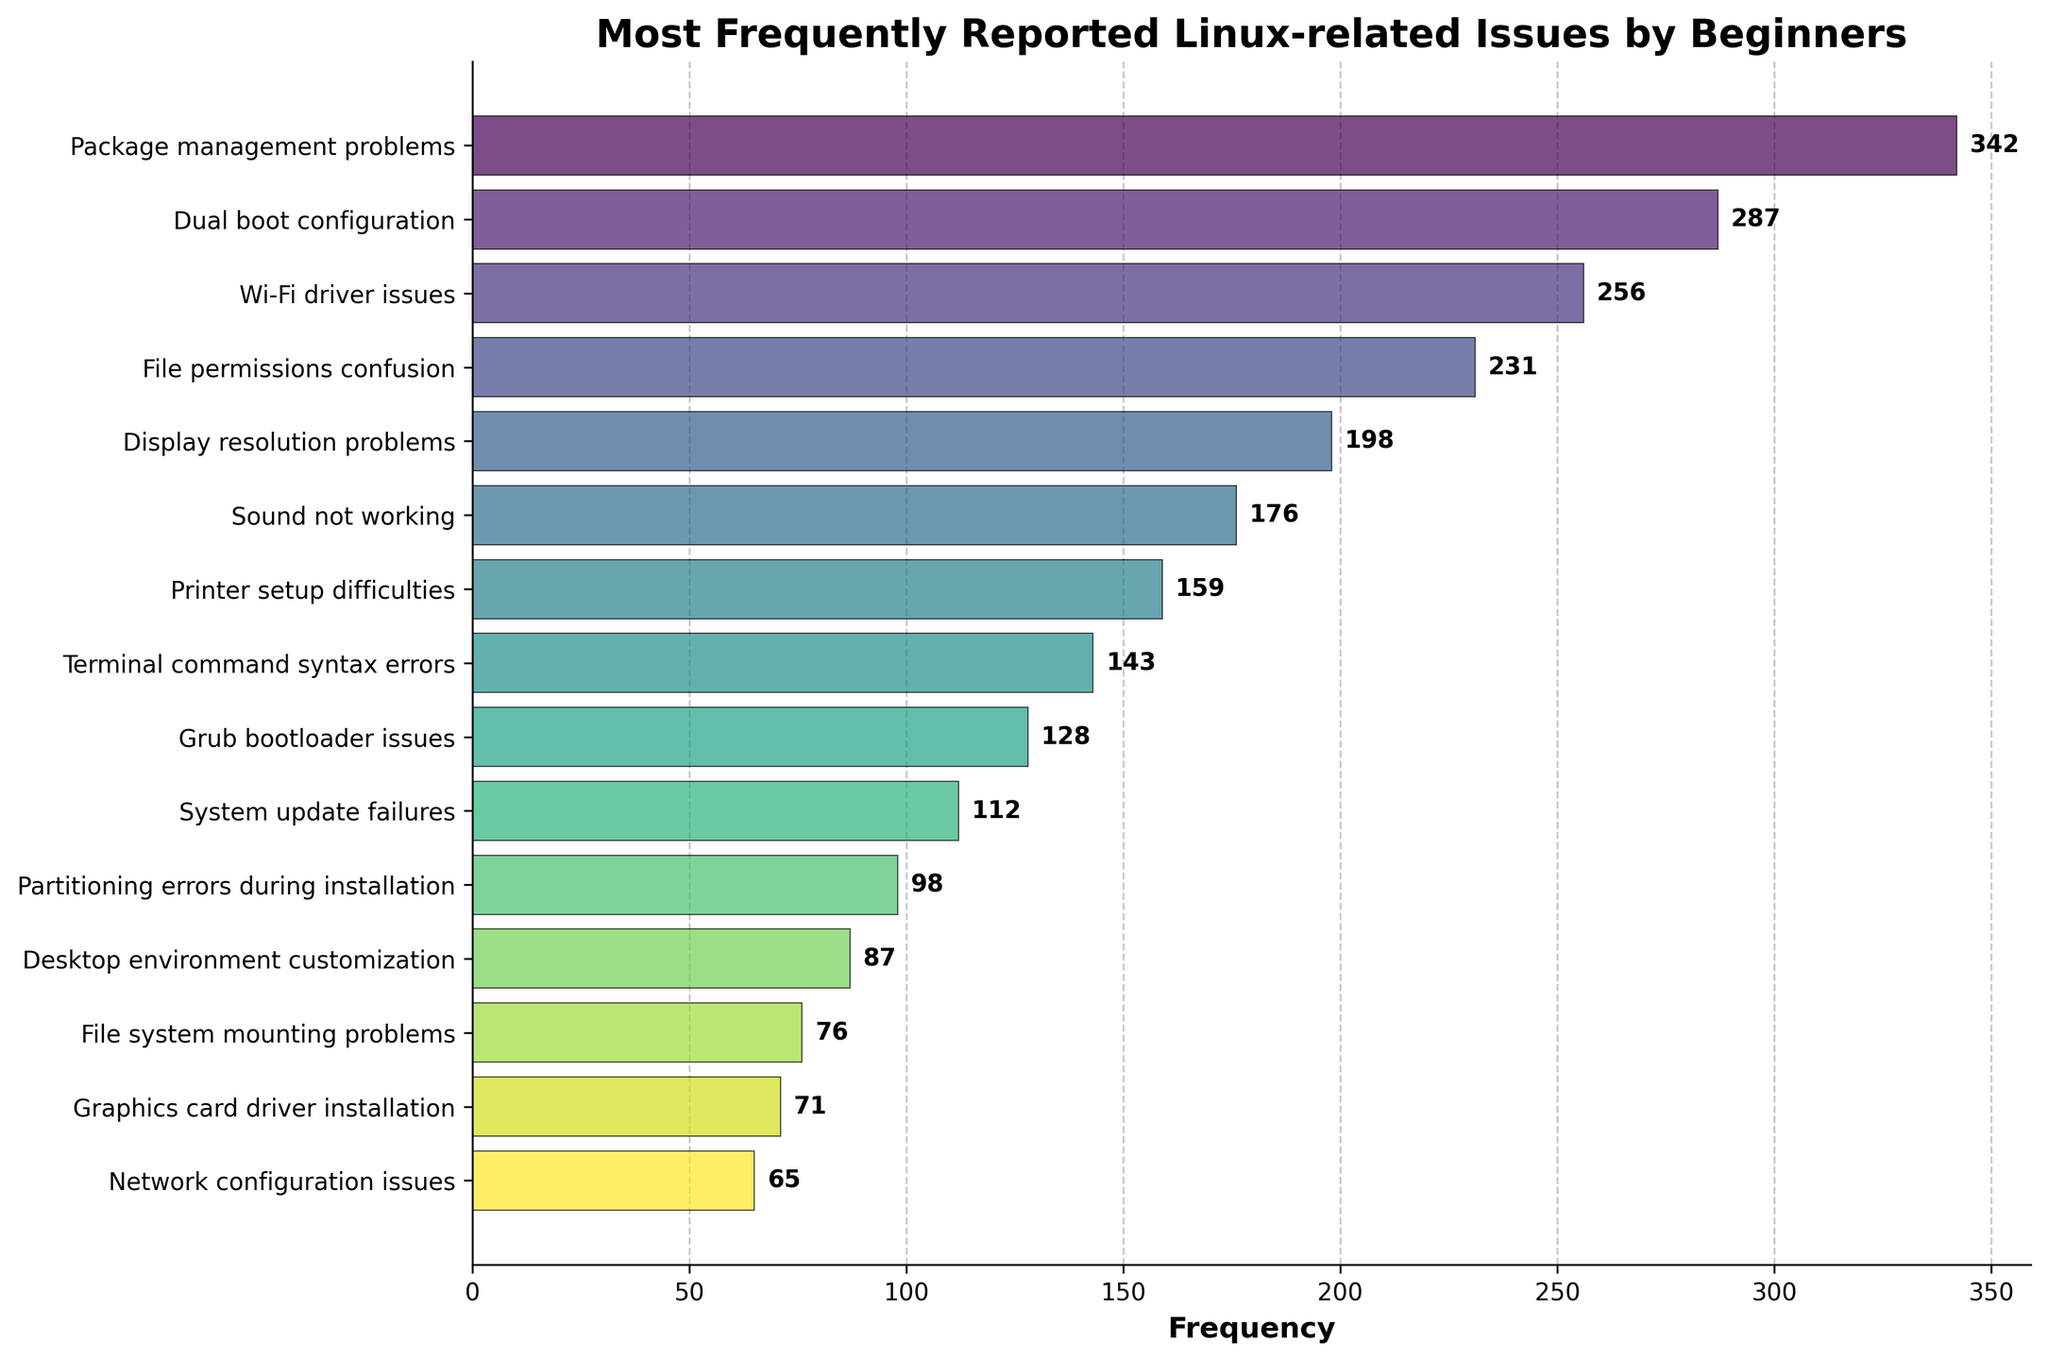What's the most frequently reported Linux-related issue by beginners? The figure shows a horizontal bar chart of various Linux-related issues reported by beginners. The longest bar, which represents the highest frequency, corresponds to "Package management problems".
Answer: Package management problems What’s the difference in frequency between "Dual boot configuration" and "Wi-Fi driver issues"? To find the difference, subtract the frequency of "Wi-Fi driver issues" from the frequency of "Dual boot configuration". According to the chart, "Dual boot configuration" has a frequency of 287 and "Wi-Fi driver issues" has a frequency of 256. So, 287 - 256 = 31.
Answer: 31 Which issue has the lowest frequency, and what is its value? By observing the chart, the shortest bar represents the lowest frequency issue. This is "Network configuration issues" with a frequency of 65.
Answer: Network configuration issues, 65 How many issues have a frequency greater than 200? To find this, count the number of bars with frequencies exceeding 200. The bars are "Package management problems" (342), "Dual boot configuration" (287), "Wi-Fi driver issues" (256), and "File permissions confusion" (231).
Answer: 4 What is the total frequency of all issues related to drivers (Wi-Fi and Graphics card)? Add the frequencies of "Wi-Fi driver issues" (256) and "Graphics card driver installation" (71). So, 256 + 71 = 327.
Answer: 327 Which issue has a frequency closest to the average frequency of all issues? To find the average frequency, sum all the frequencies and then divide by the number of issues. Sum = 342 + 287 + 256 + 231 + 198 + 176 + 159 + 143 + 128 + 112 + 98 + 87 + 76 + 71 + 65 = 2429. Number of issues = 15. Average = 2429 / 15 ≈ 162. The issue whose frequency is closest to 162 is "Printer setup difficulties" with a frequency of 159.
Answer: Printer setup difficulties Are there more issues with a frequency greater than or equal to 100 or less than 100? Count the issues with frequencies ≥ 100 and those with frequencies < 100. Frequencies ≥ 100: 11 issues. Frequencies < 100: 4 issues. So there are more issues with a frequency greater than or equal to 100.
Answer: Greater than or equal to 100 Which issue related to system booting has a higher frequency, "Dual boot configuration" or "Grub bootloader issues"? Compare the frequencies of "Dual boot configuration" (287) and "Grub bootloader issues" (128). "Dual boot configuration" has a higher frequency.
Answer: Dual boot configuration 